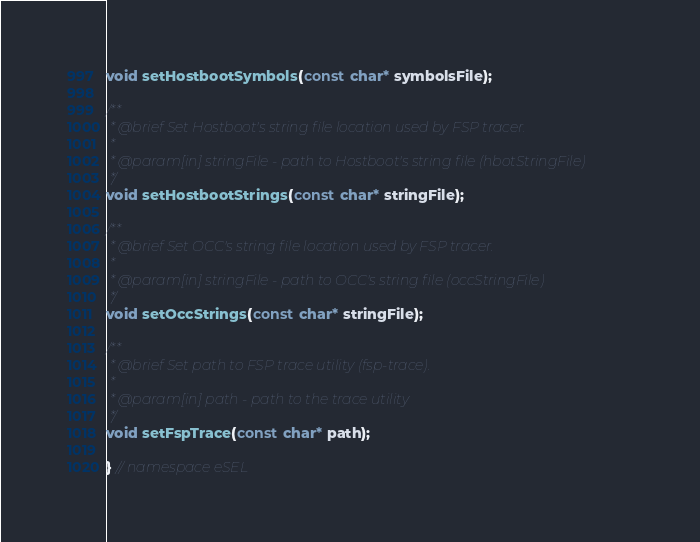<code> <loc_0><loc_0><loc_500><loc_500><_C++_>void setHostbootSymbols(const char* symbolsFile);

/**
 * @brief Set Hostboot's string file location used by FSP tracer.
 *
 * @param[in] stringFile - path to Hostboot's string file (hbotStringFile)
 */
void setHostbootStrings(const char* stringFile);

/**
 * @brief Set OCC's string file location used by FSP tracer.
 *
 * @param[in] stringFile - path to OCC's string file (occStringFile)
 */
void setOccStrings(const char* stringFile);

/**
 * @brief Set path to FSP trace utility (fsp-trace).
 *
 * @param[in] path - path to the trace utility
 */
void setFspTrace(const char* path);

} // namespace eSEL
</code> 